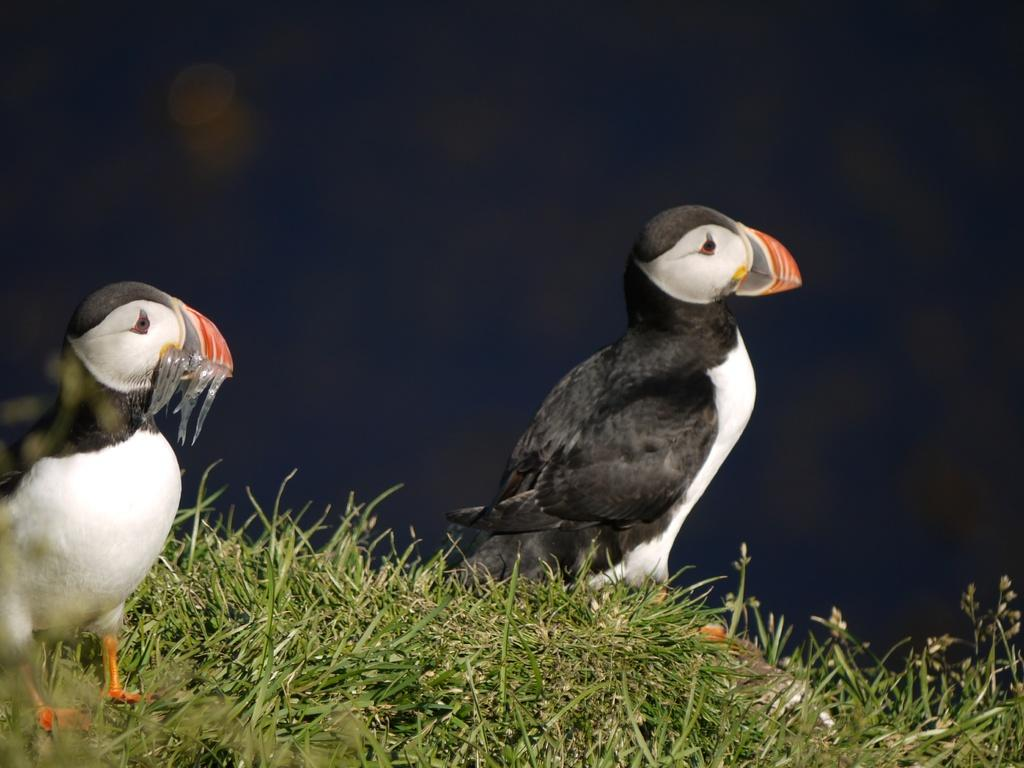What type of animals can be seen in the foreground of the image? There are birds in the foreground of the image. What type of vegetation is present in the foreground of the image? There is grass in the foreground of the image. Can you describe the background of the image? The background of the image is not clear. What type of egg is visible in the image? There is no egg present in the image. Can you describe the body of the bird in the image? There is no bird's body visible in the image, only the birds themselves. 